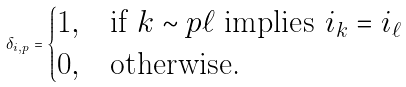Convert formula to latex. <formula><loc_0><loc_0><loc_500><loc_500>\delta _ { i , p } = \begin{cases} 1 , & \text {if } k \sim p \ell \text { implies } i _ { k } = i _ { \ell } \\ 0 , & \text {otherwise.} \end{cases}</formula> 